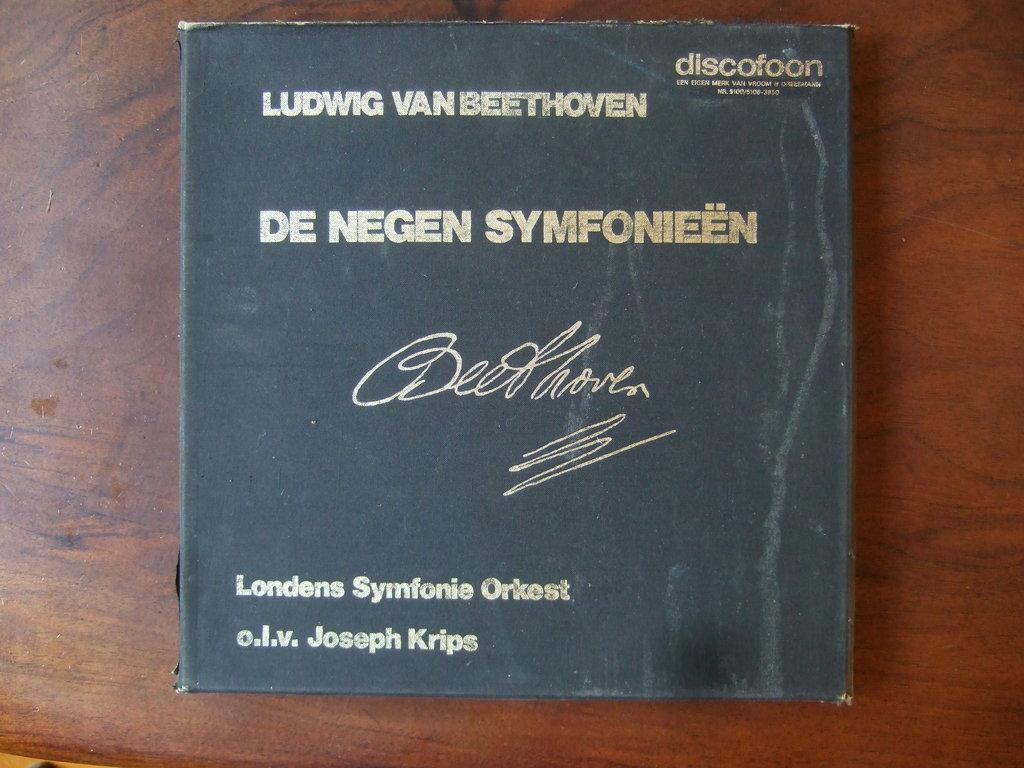Provide a one-sentence caption for the provided image. A black binder with gold lettering with the work of Ludwig Van Beethoven by the Londens Symfonie Orkest. 